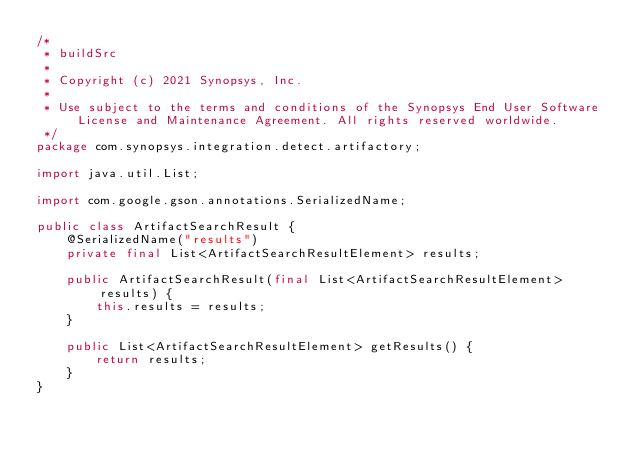Convert code to text. <code><loc_0><loc_0><loc_500><loc_500><_Java_>/*
 * buildSrc
 *
 * Copyright (c) 2021 Synopsys, Inc.
 *
 * Use subject to the terms and conditions of the Synopsys End User Software License and Maintenance Agreement. All rights reserved worldwide.
 */
package com.synopsys.integration.detect.artifactory;

import java.util.List;

import com.google.gson.annotations.SerializedName;

public class ArtifactSearchResult {
    @SerializedName("results")
    private final List<ArtifactSearchResultElement> results;

    public ArtifactSearchResult(final List<ArtifactSearchResultElement> results) {
        this.results = results;
    }

    public List<ArtifactSearchResultElement> getResults() {
        return results;
    }
}
</code> 